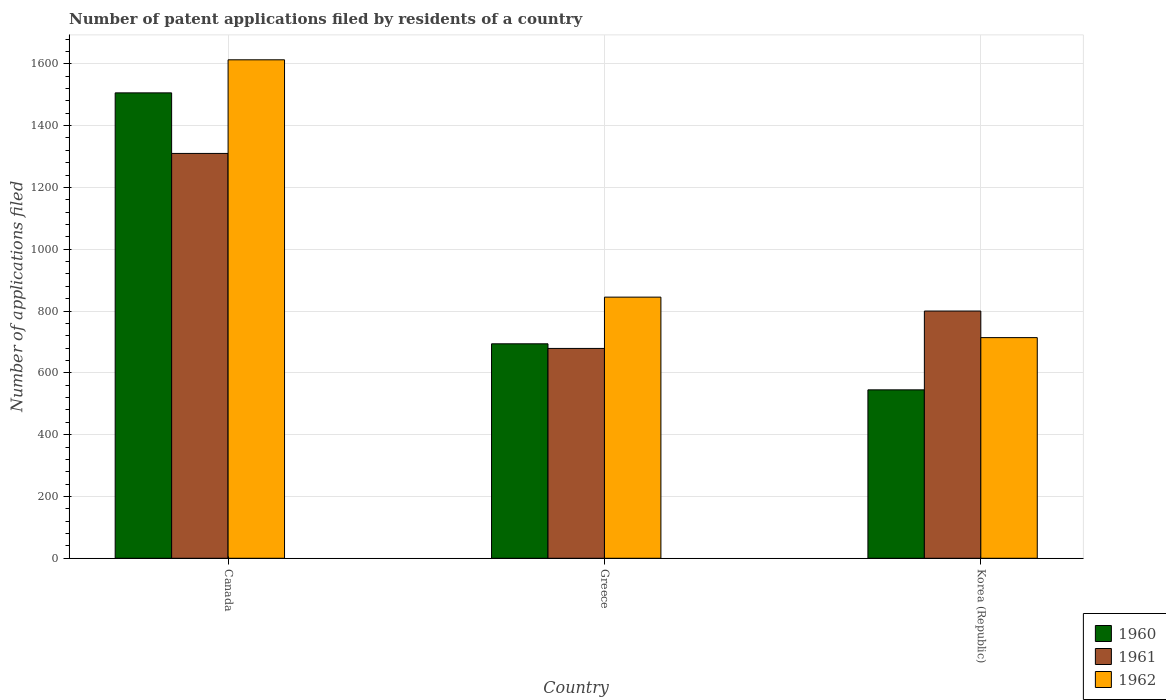Are the number of bars per tick equal to the number of legend labels?
Offer a terse response. Yes. What is the label of the 2nd group of bars from the left?
Your answer should be compact. Greece. In how many cases, is the number of bars for a given country not equal to the number of legend labels?
Your answer should be very brief. 0. What is the number of applications filed in 1961 in Greece?
Keep it short and to the point. 679. Across all countries, what is the maximum number of applications filed in 1962?
Make the answer very short. 1613. Across all countries, what is the minimum number of applications filed in 1961?
Your answer should be compact. 679. What is the total number of applications filed in 1961 in the graph?
Give a very brief answer. 2789. What is the difference between the number of applications filed in 1961 in Canada and that in Greece?
Keep it short and to the point. 631. What is the difference between the number of applications filed in 1960 in Greece and the number of applications filed in 1961 in Korea (Republic)?
Your response must be concise. -106. What is the average number of applications filed in 1961 per country?
Keep it short and to the point. 929.67. What is the difference between the number of applications filed of/in 1962 and number of applications filed of/in 1961 in Greece?
Give a very brief answer. 166. In how many countries, is the number of applications filed in 1962 greater than 360?
Make the answer very short. 3. What is the ratio of the number of applications filed in 1962 in Canada to that in Greece?
Ensure brevity in your answer.  1.91. Is the number of applications filed in 1961 in Canada less than that in Greece?
Give a very brief answer. No. Is the difference between the number of applications filed in 1962 in Canada and Greece greater than the difference between the number of applications filed in 1961 in Canada and Greece?
Your response must be concise. Yes. What is the difference between the highest and the second highest number of applications filed in 1962?
Give a very brief answer. -131. What is the difference between the highest and the lowest number of applications filed in 1962?
Keep it short and to the point. 899. What does the 1st bar from the left in Canada represents?
Your answer should be very brief. 1960. Is it the case that in every country, the sum of the number of applications filed in 1960 and number of applications filed in 1962 is greater than the number of applications filed in 1961?
Provide a short and direct response. Yes. How many bars are there?
Ensure brevity in your answer.  9. How many countries are there in the graph?
Offer a very short reply. 3. Are the values on the major ticks of Y-axis written in scientific E-notation?
Provide a short and direct response. No. How are the legend labels stacked?
Give a very brief answer. Vertical. What is the title of the graph?
Your response must be concise. Number of patent applications filed by residents of a country. What is the label or title of the X-axis?
Your answer should be very brief. Country. What is the label or title of the Y-axis?
Keep it short and to the point. Number of applications filed. What is the Number of applications filed in 1960 in Canada?
Keep it short and to the point. 1506. What is the Number of applications filed of 1961 in Canada?
Offer a terse response. 1310. What is the Number of applications filed of 1962 in Canada?
Provide a succinct answer. 1613. What is the Number of applications filed in 1960 in Greece?
Provide a succinct answer. 694. What is the Number of applications filed in 1961 in Greece?
Make the answer very short. 679. What is the Number of applications filed of 1962 in Greece?
Give a very brief answer. 845. What is the Number of applications filed of 1960 in Korea (Republic)?
Make the answer very short. 545. What is the Number of applications filed of 1961 in Korea (Republic)?
Offer a terse response. 800. What is the Number of applications filed of 1962 in Korea (Republic)?
Your response must be concise. 714. Across all countries, what is the maximum Number of applications filed of 1960?
Your answer should be very brief. 1506. Across all countries, what is the maximum Number of applications filed in 1961?
Provide a short and direct response. 1310. Across all countries, what is the maximum Number of applications filed in 1962?
Give a very brief answer. 1613. Across all countries, what is the minimum Number of applications filed in 1960?
Make the answer very short. 545. Across all countries, what is the minimum Number of applications filed of 1961?
Give a very brief answer. 679. Across all countries, what is the minimum Number of applications filed of 1962?
Offer a terse response. 714. What is the total Number of applications filed in 1960 in the graph?
Your answer should be compact. 2745. What is the total Number of applications filed in 1961 in the graph?
Offer a terse response. 2789. What is the total Number of applications filed in 1962 in the graph?
Provide a succinct answer. 3172. What is the difference between the Number of applications filed of 1960 in Canada and that in Greece?
Ensure brevity in your answer.  812. What is the difference between the Number of applications filed in 1961 in Canada and that in Greece?
Ensure brevity in your answer.  631. What is the difference between the Number of applications filed of 1962 in Canada and that in Greece?
Keep it short and to the point. 768. What is the difference between the Number of applications filed of 1960 in Canada and that in Korea (Republic)?
Provide a short and direct response. 961. What is the difference between the Number of applications filed in 1961 in Canada and that in Korea (Republic)?
Provide a short and direct response. 510. What is the difference between the Number of applications filed in 1962 in Canada and that in Korea (Republic)?
Your response must be concise. 899. What is the difference between the Number of applications filed in 1960 in Greece and that in Korea (Republic)?
Your answer should be compact. 149. What is the difference between the Number of applications filed of 1961 in Greece and that in Korea (Republic)?
Offer a terse response. -121. What is the difference between the Number of applications filed of 1962 in Greece and that in Korea (Republic)?
Provide a succinct answer. 131. What is the difference between the Number of applications filed of 1960 in Canada and the Number of applications filed of 1961 in Greece?
Provide a succinct answer. 827. What is the difference between the Number of applications filed of 1960 in Canada and the Number of applications filed of 1962 in Greece?
Offer a very short reply. 661. What is the difference between the Number of applications filed in 1961 in Canada and the Number of applications filed in 1962 in Greece?
Give a very brief answer. 465. What is the difference between the Number of applications filed of 1960 in Canada and the Number of applications filed of 1961 in Korea (Republic)?
Offer a very short reply. 706. What is the difference between the Number of applications filed of 1960 in Canada and the Number of applications filed of 1962 in Korea (Republic)?
Provide a succinct answer. 792. What is the difference between the Number of applications filed in 1961 in Canada and the Number of applications filed in 1962 in Korea (Republic)?
Ensure brevity in your answer.  596. What is the difference between the Number of applications filed of 1960 in Greece and the Number of applications filed of 1961 in Korea (Republic)?
Offer a very short reply. -106. What is the difference between the Number of applications filed of 1960 in Greece and the Number of applications filed of 1962 in Korea (Republic)?
Make the answer very short. -20. What is the difference between the Number of applications filed of 1961 in Greece and the Number of applications filed of 1962 in Korea (Republic)?
Make the answer very short. -35. What is the average Number of applications filed in 1960 per country?
Your answer should be compact. 915. What is the average Number of applications filed in 1961 per country?
Your answer should be compact. 929.67. What is the average Number of applications filed of 1962 per country?
Make the answer very short. 1057.33. What is the difference between the Number of applications filed of 1960 and Number of applications filed of 1961 in Canada?
Offer a very short reply. 196. What is the difference between the Number of applications filed in 1960 and Number of applications filed in 1962 in Canada?
Keep it short and to the point. -107. What is the difference between the Number of applications filed of 1961 and Number of applications filed of 1962 in Canada?
Offer a terse response. -303. What is the difference between the Number of applications filed of 1960 and Number of applications filed of 1961 in Greece?
Your answer should be very brief. 15. What is the difference between the Number of applications filed of 1960 and Number of applications filed of 1962 in Greece?
Offer a very short reply. -151. What is the difference between the Number of applications filed of 1961 and Number of applications filed of 1962 in Greece?
Ensure brevity in your answer.  -166. What is the difference between the Number of applications filed of 1960 and Number of applications filed of 1961 in Korea (Republic)?
Your response must be concise. -255. What is the difference between the Number of applications filed in 1960 and Number of applications filed in 1962 in Korea (Republic)?
Ensure brevity in your answer.  -169. What is the difference between the Number of applications filed in 1961 and Number of applications filed in 1962 in Korea (Republic)?
Keep it short and to the point. 86. What is the ratio of the Number of applications filed in 1960 in Canada to that in Greece?
Offer a very short reply. 2.17. What is the ratio of the Number of applications filed of 1961 in Canada to that in Greece?
Keep it short and to the point. 1.93. What is the ratio of the Number of applications filed of 1962 in Canada to that in Greece?
Your response must be concise. 1.91. What is the ratio of the Number of applications filed of 1960 in Canada to that in Korea (Republic)?
Ensure brevity in your answer.  2.76. What is the ratio of the Number of applications filed of 1961 in Canada to that in Korea (Republic)?
Your answer should be very brief. 1.64. What is the ratio of the Number of applications filed of 1962 in Canada to that in Korea (Republic)?
Keep it short and to the point. 2.26. What is the ratio of the Number of applications filed in 1960 in Greece to that in Korea (Republic)?
Your response must be concise. 1.27. What is the ratio of the Number of applications filed in 1961 in Greece to that in Korea (Republic)?
Provide a short and direct response. 0.85. What is the ratio of the Number of applications filed in 1962 in Greece to that in Korea (Republic)?
Offer a very short reply. 1.18. What is the difference between the highest and the second highest Number of applications filed in 1960?
Provide a short and direct response. 812. What is the difference between the highest and the second highest Number of applications filed of 1961?
Ensure brevity in your answer.  510. What is the difference between the highest and the second highest Number of applications filed of 1962?
Make the answer very short. 768. What is the difference between the highest and the lowest Number of applications filed in 1960?
Provide a succinct answer. 961. What is the difference between the highest and the lowest Number of applications filed of 1961?
Keep it short and to the point. 631. What is the difference between the highest and the lowest Number of applications filed of 1962?
Your answer should be compact. 899. 